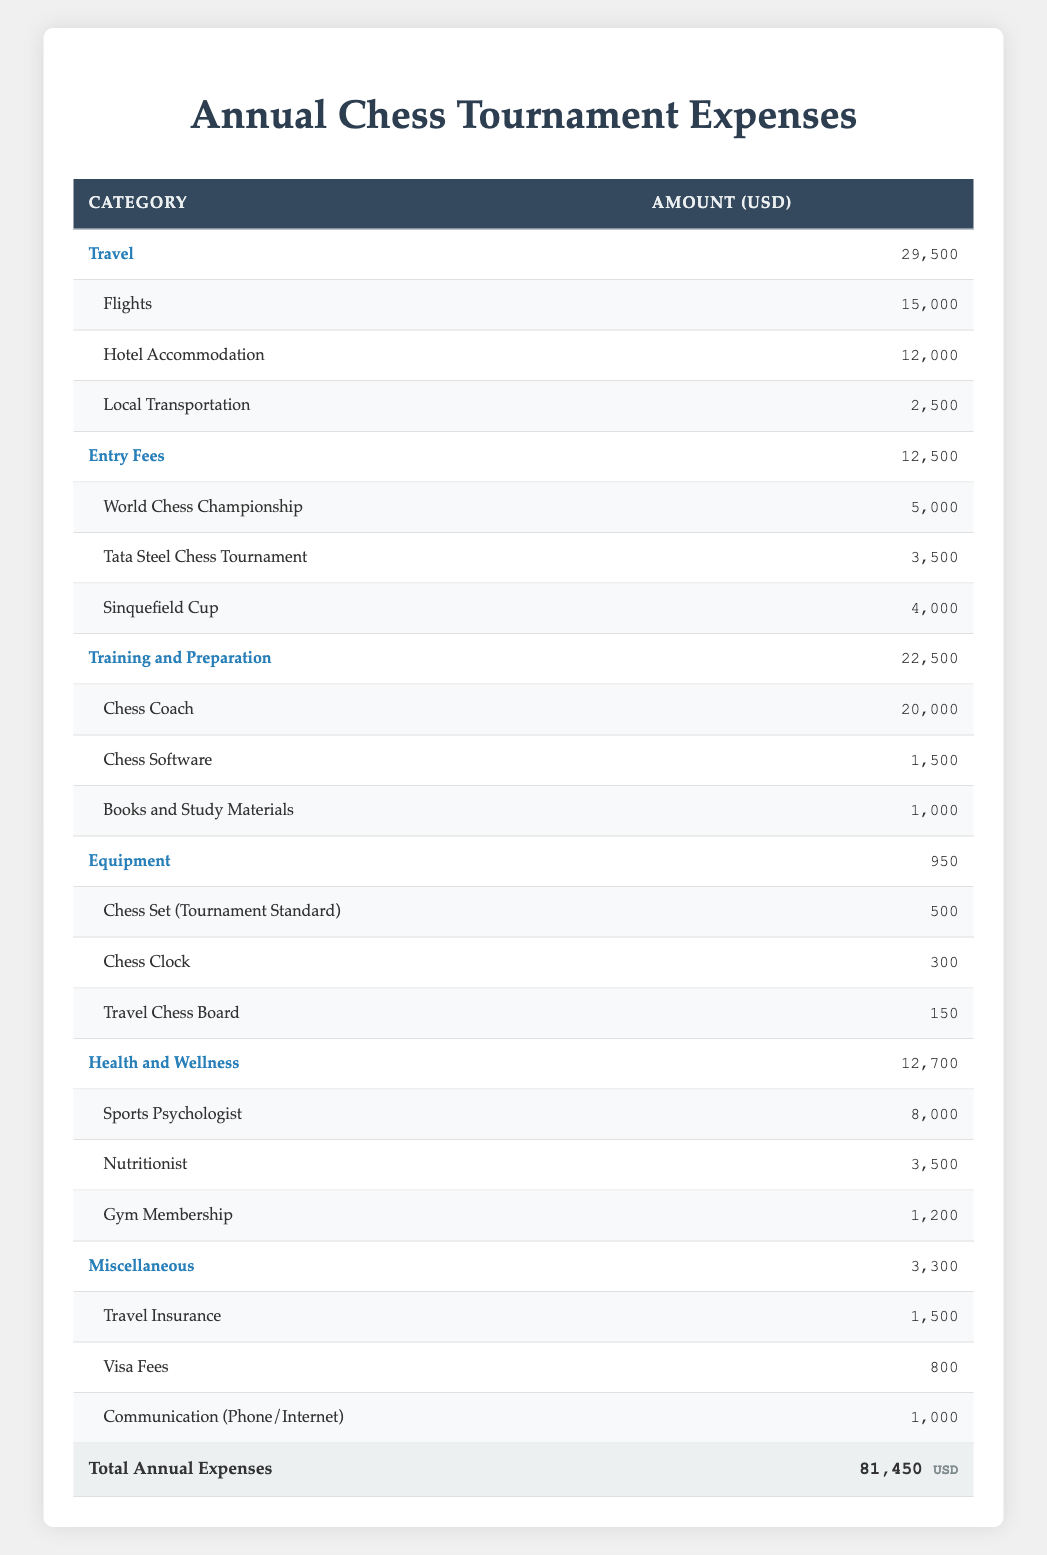What is the total amount spent on Travel? The table shows the "Travel" category with a total amount of 29,500 USD, which includes subcategories: Flights (15,000), Hotel Accommodation (12,000), and Local Transportation (2,500). The total is explicitly stated.
Answer: 29,500 USD What is the sum of the Entry Fees for the three tournaments? The Entry Fees category includes World Chess Championship (5,000), Tata Steel Chess Tournament (3,500), and Sinquefield Cup (4,000). Adding these amounts: 5,000 + 3,500 + 4,000 = 12,500 USD.
Answer: 12,500 USD Is the amount spent on Training and Preparation higher than that spent on Health and Wellness? The table shows 22,500 USD for Training and Preparation and 12,700 USD for Health and Wellness. Since 22,500 is greater than 12,700, the statement is true.
Answer: Yes What is the amount allocated for equipment in total? The Equipment category lists Chess Set (500), Chess Clock (300), and Travel Chess Board (150), summing these gives: 500 + 300 + 150 = 950 USD, which is directly mentioned in the table.
Answer: 950 USD If the total expenses are 81,450 USD, what percentage does the Travel category represent? The Travel category is 29,500 USD, so to find its percentage of total expenses, calculate: (29,500 / 81,450) * 100 = 36.24%, approximating it to two decimal points gives 36.24%.
Answer: 36.24% Which subcategory of Health and Wellness has the highest expense? Among the subcategories: Sports Psychologist (8,000), Nutritionist (3,500), and Gym Membership (1,200), Sports Psychologist has the highest amount at 8,000 USD.
Answer: Sports Psychologist How much does the Sports Psychologist's services cost compared to the total annual expenses? The Sports Psychologist costs 8,000 USD while the total expenses are 81,450 USD. To find the percentage cost, compute: (8,000 / 81,450) * 100 = 9.83%. This indicates that the cost of the Sports Psychologist comprises 9.83% of the total expenses.
Answer: 9.83% What is the total amount spent on Miscellaneous expenses? The Miscellaneous category includes Travel Insurance (1,500), Visa Fees (800), and Communication (1,000). Summing these gives: 1,500 + 800 + 1,000 = 3,300 USD, which is confirmed in the table.
Answer: 3,300 USD How much less is spent on the Nutritionist compared to the total spent on Training and Preparation? The total for Training and Preparation is 22,500 USD, while the Nutritionist costs 3,500 USD. To find the difference: 22,500 - 3,500 = 19,000 USD. This indicates that 19,000 USD less is spent on the Nutritionist.
Answer: 19,000 USD 